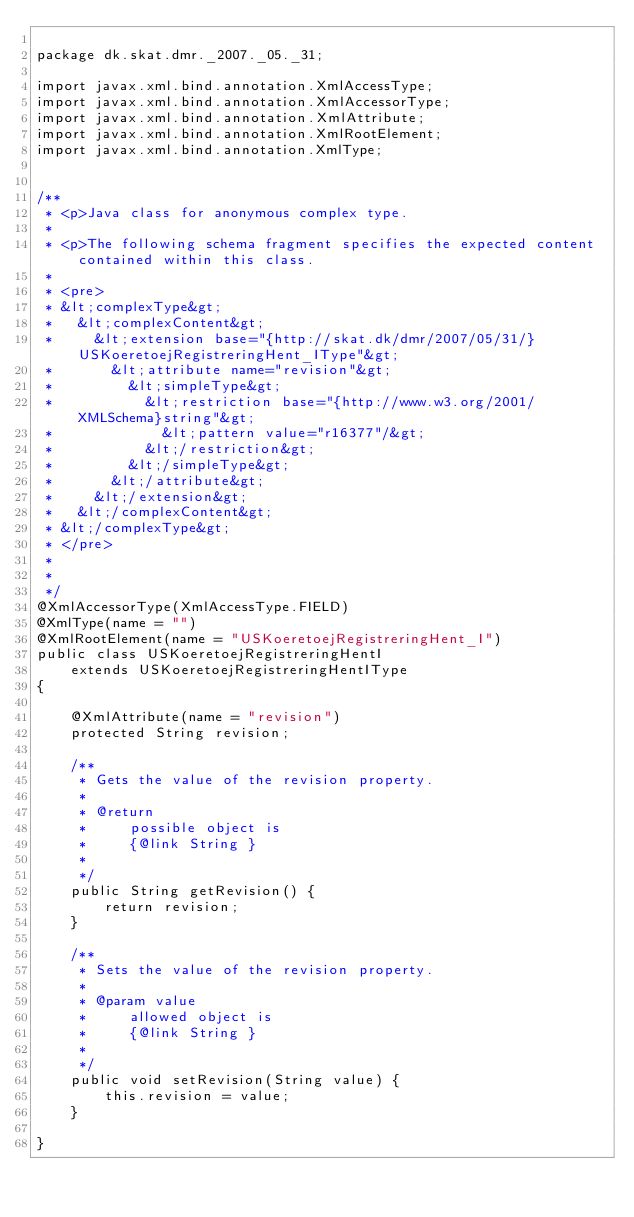Convert code to text. <code><loc_0><loc_0><loc_500><loc_500><_Java_>
package dk.skat.dmr._2007._05._31;

import javax.xml.bind.annotation.XmlAccessType;
import javax.xml.bind.annotation.XmlAccessorType;
import javax.xml.bind.annotation.XmlAttribute;
import javax.xml.bind.annotation.XmlRootElement;
import javax.xml.bind.annotation.XmlType;


/**
 * <p>Java class for anonymous complex type.
 * 
 * <p>The following schema fragment specifies the expected content contained within this class.
 * 
 * <pre>
 * &lt;complexType&gt;
 *   &lt;complexContent&gt;
 *     &lt;extension base="{http://skat.dk/dmr/2007/05/31/}USKoeretoejRegistreringHent_IType"&gt;
 *       &lt;attribute name="revision"&gt;
 *         &lt;simpleType&gt;
 *           &lt;restriction base="{http://www.w3.org/2001/XMLSchema}string"&gt;
 *             &lt;pattern value="r16377"/&gt;
 *           &lt;/restriction&gt;
 *         &lt;/simpleType&gt;
 *       &lt;/attribute&gt;
 *     &lt;/extension&gt;
 *   &lt;/complexContent&gt;
 * &lt;/complexType&gt;
 * </pre>
 * 
 * 
 */
@XmlAccessorType(XmlAccessType.FIELD)
@XmlType(name = "")
@XmlRootElement(name = "USKoeretoejRegistreringHent_I")
public class USKoeretoejRegistreringHentI
    extends USKoeretoejRegistreringHentIType
{

    @XmlAttribute(name = "revision")
    protected String revision;

    /**
     * Gets the value of the revision property.
     * 
     * @return
     *     possible object is
     *     {@link String }
     *     
     */
    public String getRevision() {
        return revision;
    }

    /**
     * Sets the value of the revision property.
     * 
     * @param value
     *     allowed object is
     *     {@link String }
     *     
     */
    public void setRevision(String value) {
        this.revision = value;
    }

}
</code> 